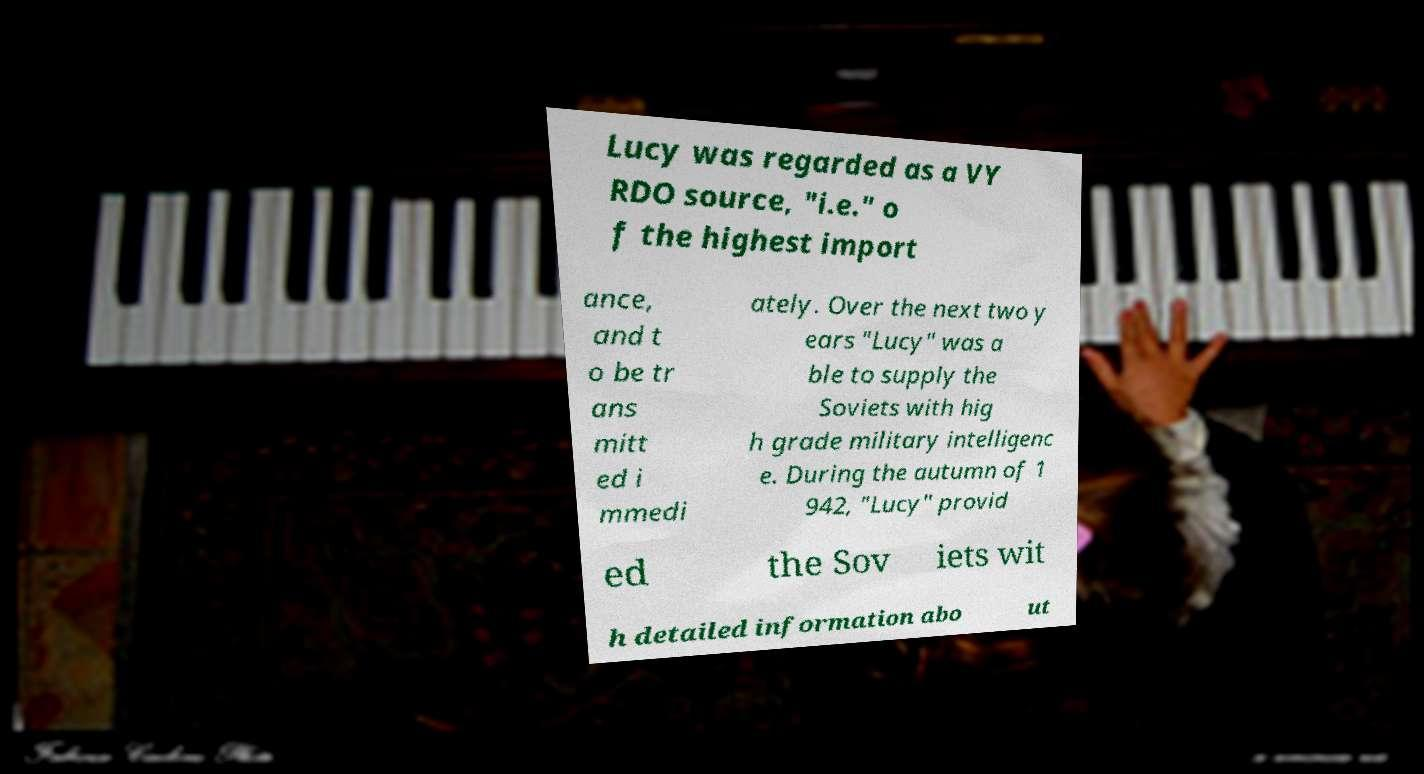There's text embedded in this image that I need extracted. Can you transcribe it verbatim? Lucy was regarded as a VY RDO source, "i.e." o f the highest import ance, and t o be tr ans mitt ed i mmedi ately. Over the next two y ears "Lucy" was a ble to supply the Soviets with hig h grade military intelligenc e. During the autumn of 1 942, "Lucy" provid ed the Sov iets wit h detailed information abo ut 